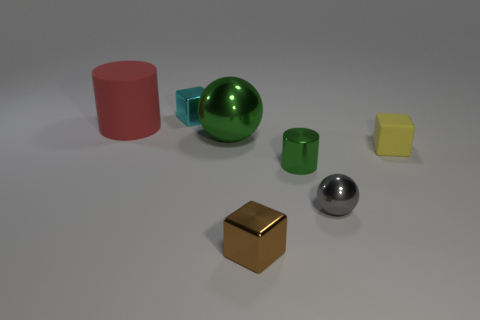Add 3 small matte things. How many objects exist? 10 Subtract all cylinders. How many objects are left? 5 Subtract all big yellow things. Subtract all gray metallic balls. How many objects are left? 6 Add 3 tiny brown cubes. How many tiny brown cubes are left? 4 Add 4 small green rubber cubes. How many small green rubber cubes exist? 4 Subtract 1 yellow cubes. How many objects are left? 6 